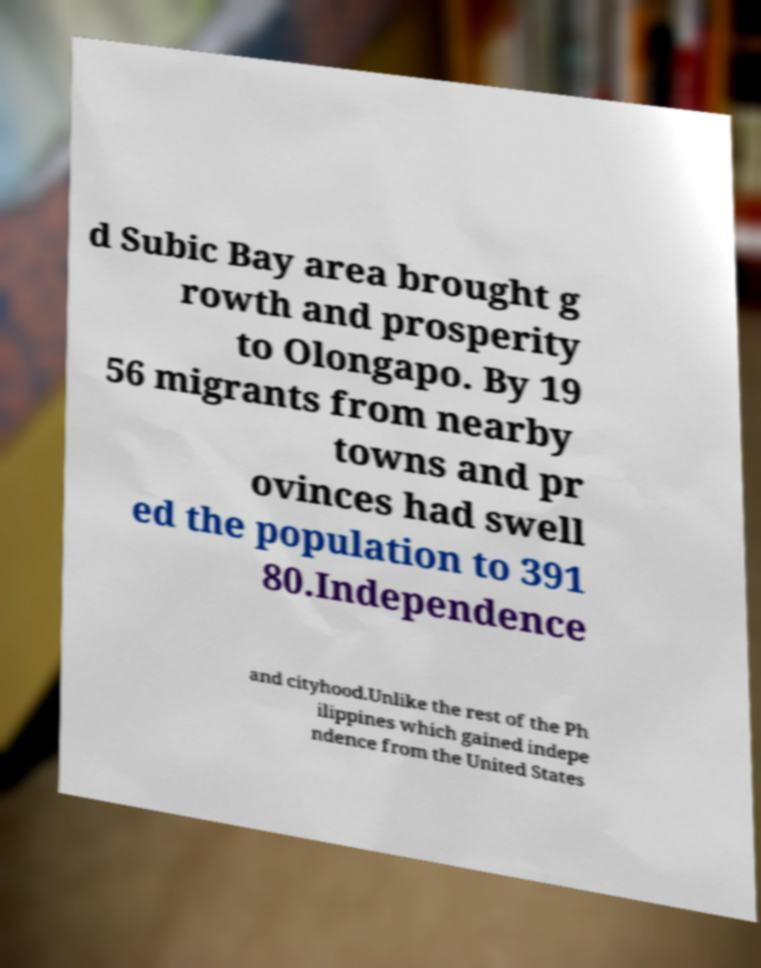There's text embedded in this image that I need extracted. Can you transcribe it verbatim? d Subic Bay area brought g rowth and prosperity to Olongapo. By 19 56 migrants from nearby towns and pr ovinces had swell ed the population to 391 80.Independence and cityhood.Unlike the rest of the Ph ilippines which gained indepe ndence from the United States 